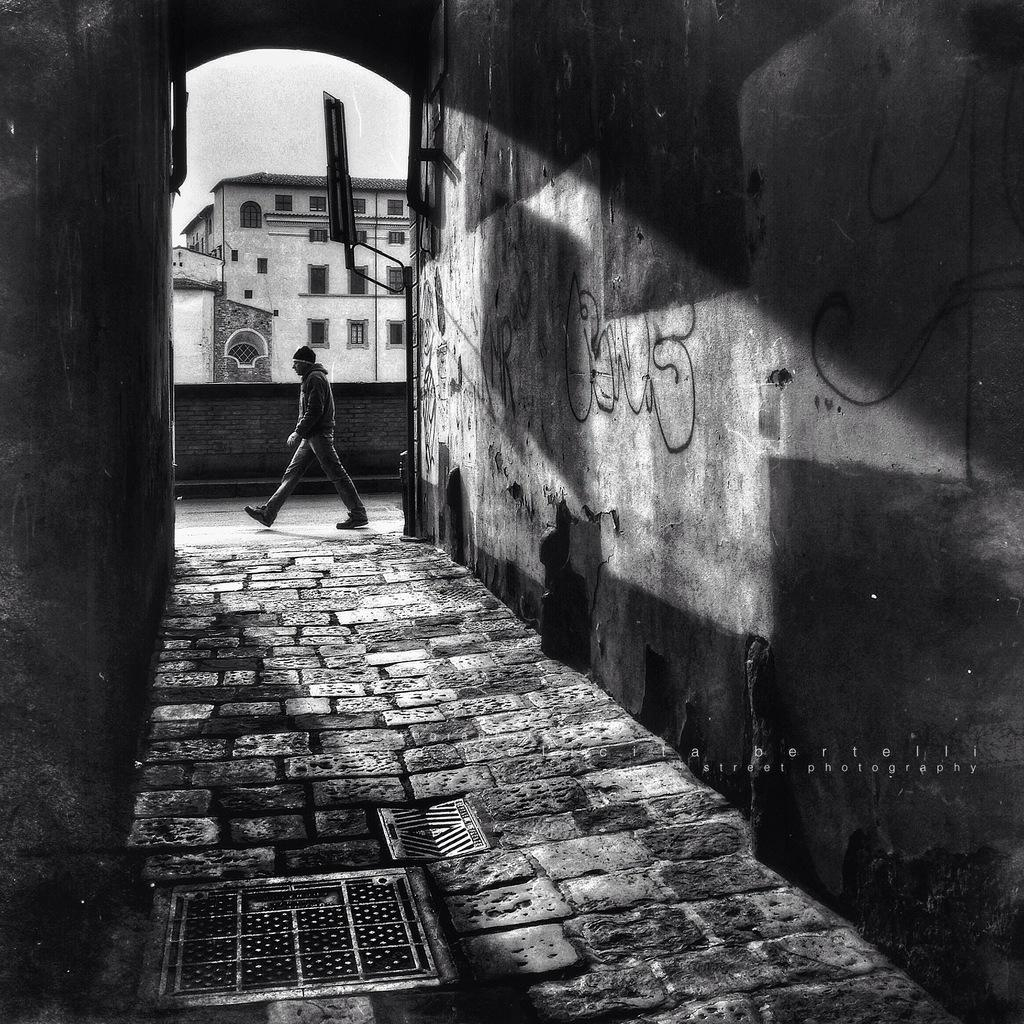Who is present in the image? There is a man in the image. What type of surface is visible under the man's feet? There is pavement in the image. What structures are visible in the image? There are walls and buildings in the image. What can be seen in the distance behind the walls and buildings? The sky is visible in the background of the image. What type of cub can be seen interacting with the calculator in the image? There is no cub or calculator present in the image. 